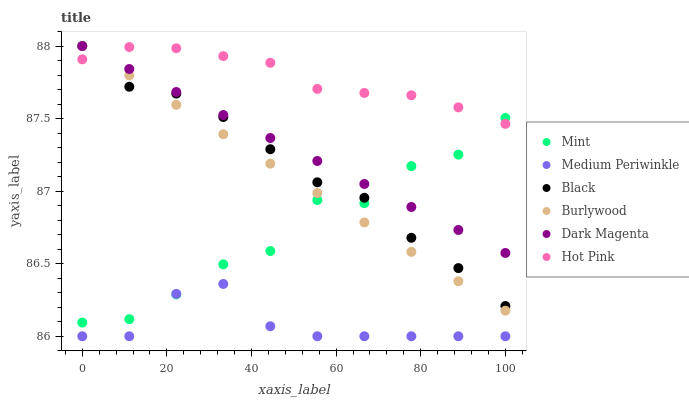Does Medium Periwinkle have the minimum area under the curve?
Answer yes or no. Yes. Does Hot Pink have the maximum area under the curve?
Answer yes or no. Yes. Does Burlywood have the minimum area under the curve?
Answer yes or no. No. Does Burlywood have the maximum area under the curve?
Answer yes or no. No. Is Burlywood the smoothest?
Answer yes or no. Yes. Is Mint the roughest?
Answer yes or no. Yes. Is Hot Pink the smoothest?
Answer yes or no. No. Is Hot Pink the roughest?
Answer yes or no. No. Does Medium Periwinkle have the lowest value?
Answer yes or no. Yes. Does Burlywood have the lowest value?
Answer yes or no. No. Does Black have the highest value?
Answer yes or no. Yes. Does Hot Pink have the highest value?
Answer yes or no. No. Is Medium Periwinkle less than Dark Magenta?
Answer yes or no. Yes. Is Burlywood greater than Medium Periwinkle?
Answer yes or no. Yes. Does Burlywood intersect Dark Magenta?
Answer yes or no. Yes. Is Burlywood less than Dark Magenta?
Answer yes or no. No. Is Burlywood greater than Dark Magenta?
Answer yes or no. No. Does Medium Periwinkle intersect Dark Magenta?
Answer yes or no. No. 